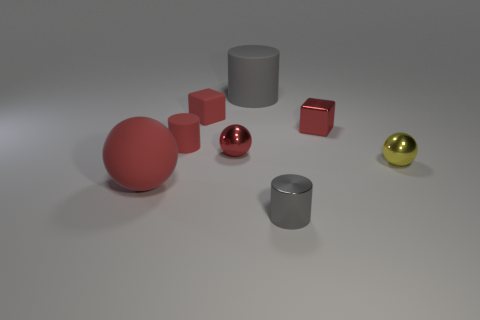Add 1 yellow spheres. How many objects exist? 9 Subtract all blocks. How many objects are left? 6 Add 7 tiny red cylinders. How many tiny red cylinders exist? 8 Subtract 0 purple balls. How many objects are left? 8 Subtract all red cylinders. Subtract all red metallic things. How many objects are left? 5 Add 3 tiny red metallic objects. How many tiny red metallic objects are left? 5 